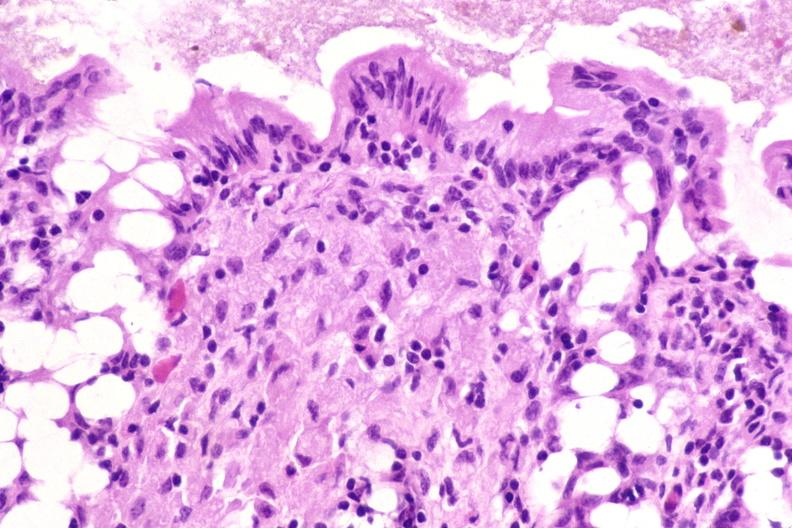does thecoma show colon biopsy, mycobacterium avium-intracellularae?
Answer the question using a single word or phrase. No 